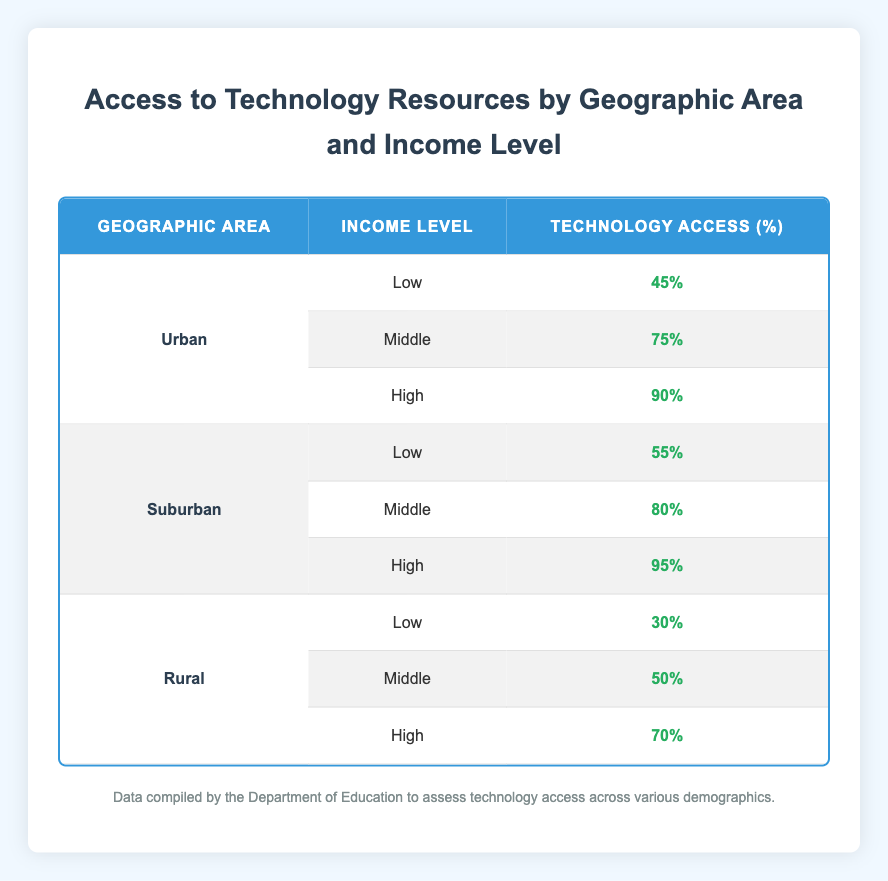What is the technology access percentage for low-income individuals in rural areas? According to the table, the technology access percentage for low-income individuals in rural areas is listed as 30%.
Answer: 30% What is the difference in technology access between high-income individuals in urban and suburban areas? From the table, the technology access for high-income individuals in urban areas is 90% and in suburban areas is 95%. Therefore, the difference is 95% - 90% = 5%.
Answer: 5% Does suburban technology access for middle-income individuals exceed 70%? The table states that technology access for middle-income individuals in suburban areas is 80%, which is greater than 70%. Therefore, the answer is yes.
Answer: Yes What is the average technology access for all low-income individuals across the three geographic areas? From the data, the technology access percentages for low-income individuals are 45% (Urban), 55% (Suburban), and 30% (Rural). To find the average, I sum these values: 45 + 55 + 30 = 130, and then divide by 3: 130/3 ≈ 43.33%.
Answer: 43.33% Which income group has the highest technology access in rural areas? The table shows that the technology access percentages in rural areas are 30% (Low), 50% (Middle), and 70% (High). The highest percentage is 70%, which corresponds to high-income individuals.
Answer: High How does urban technology access for middle-income individuals compare to the rural middle-income levels? From the table, urban technology access for middle-income individuals is 75%, while rural technology access for middle-income individuals is 50%. Thus, urban technology access is higher by 75% - 50% = 25%.
Answer: 25% Is it true that low-income individuals in urban areas have better technology access than rural low-income individuals? The table indicates that urban low-income individuals have a technology access of 45%, while rural low-income individuals have 30%. Since 45% is greater than 30%, the answer is true.
Answer: True What percentage of technology access do middle-income individuals in urban areas have compared to suburban areas? The technology access for middle-income individuals in urban areas is 75%, while in suburban areas it is 80%. Therefore, suburban middle-income individuals have 5% more access than their urban counterparts.
Answer: 5% 